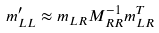<formula> <loc_0><loc_0><loc_500><loc_500>m _ { L L } ^ { \prime } \approx m _ { L R } M _ { R R } ^ { - 1 } m _ { L R } ^ { T }</formula> 